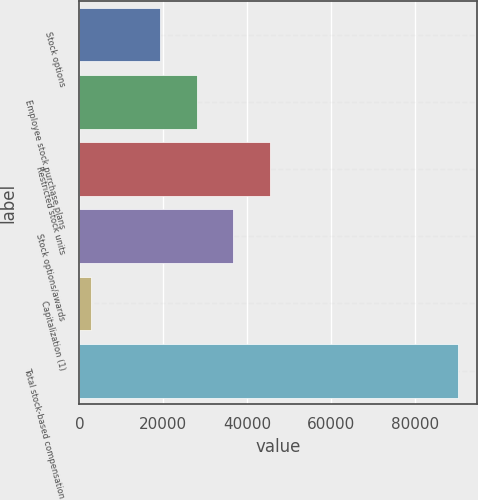<chart> <loc_0><loc_0><loc_500><loc_500><bar_chart><fcel>Stock options<fcel>Employee stock purchase plans<fcel>Restricted stock units<fcel>Stock options/awards<fcel>Capitalization (1)<fcel>Total stock-based compensation<nl><fcel>19191<fcel>27926.6<fcel>45397.8<fcel>36662.2<fcel>2710<fcel>90066<nl></chart> 